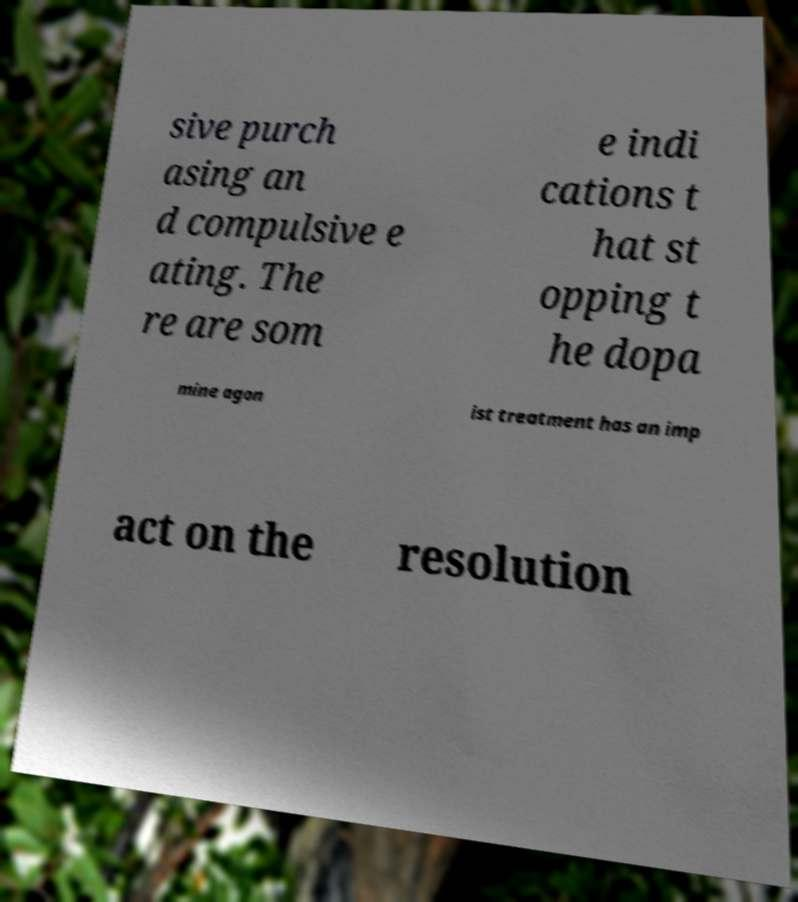What messages or text are displayed in this image? I need them in a readable, typed format. sive purch asing an d compulsive e ating. The re are som e indi cations t hat st opping t he dopa mine agon ist treatment has an imp act on the resolution 